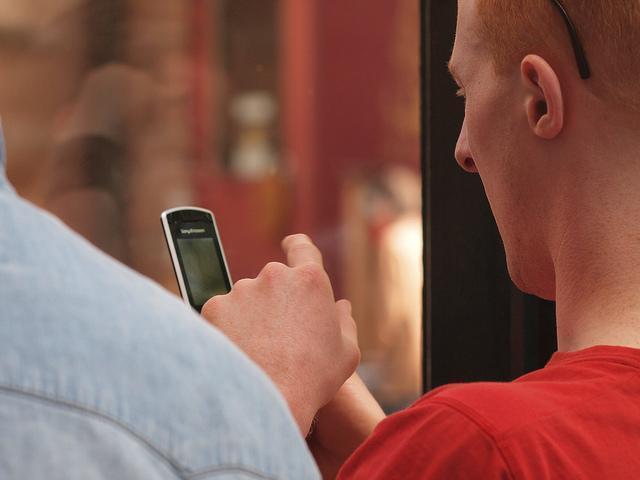The bald man with glasses is using what kind of phone?
Indicate the correct response by choosing from the four available options to answer the question.
Options: Flip, iphone, blackberry, smart. Flip. 